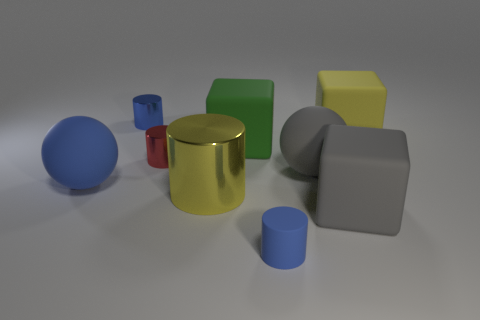Subtract all red cylinders. How many cylinders are left? 3 Subtract all blue cubes. How many blue cylinders are left? 2 Subtract all red cylinders. How many cylinders are left? 3 Subtract 3 cylinders. How many cylinders are left? 1 Add 1 big metallic cylinders. How many big metallic cylinders exist? 2 Subtract 0 cyan balls. How many objects are left? 9 Subtract all blocks. How many objects are left? 6 Subtract all brown cylinders. Subtract all blue spheres. How many cylinders are left? 4 Subtract all cylinders. Subtract all small shiny things. How many objects are left? 3 Add 8 large yellow metal cylinders. How many large yellow metal cylinders are left? 9 